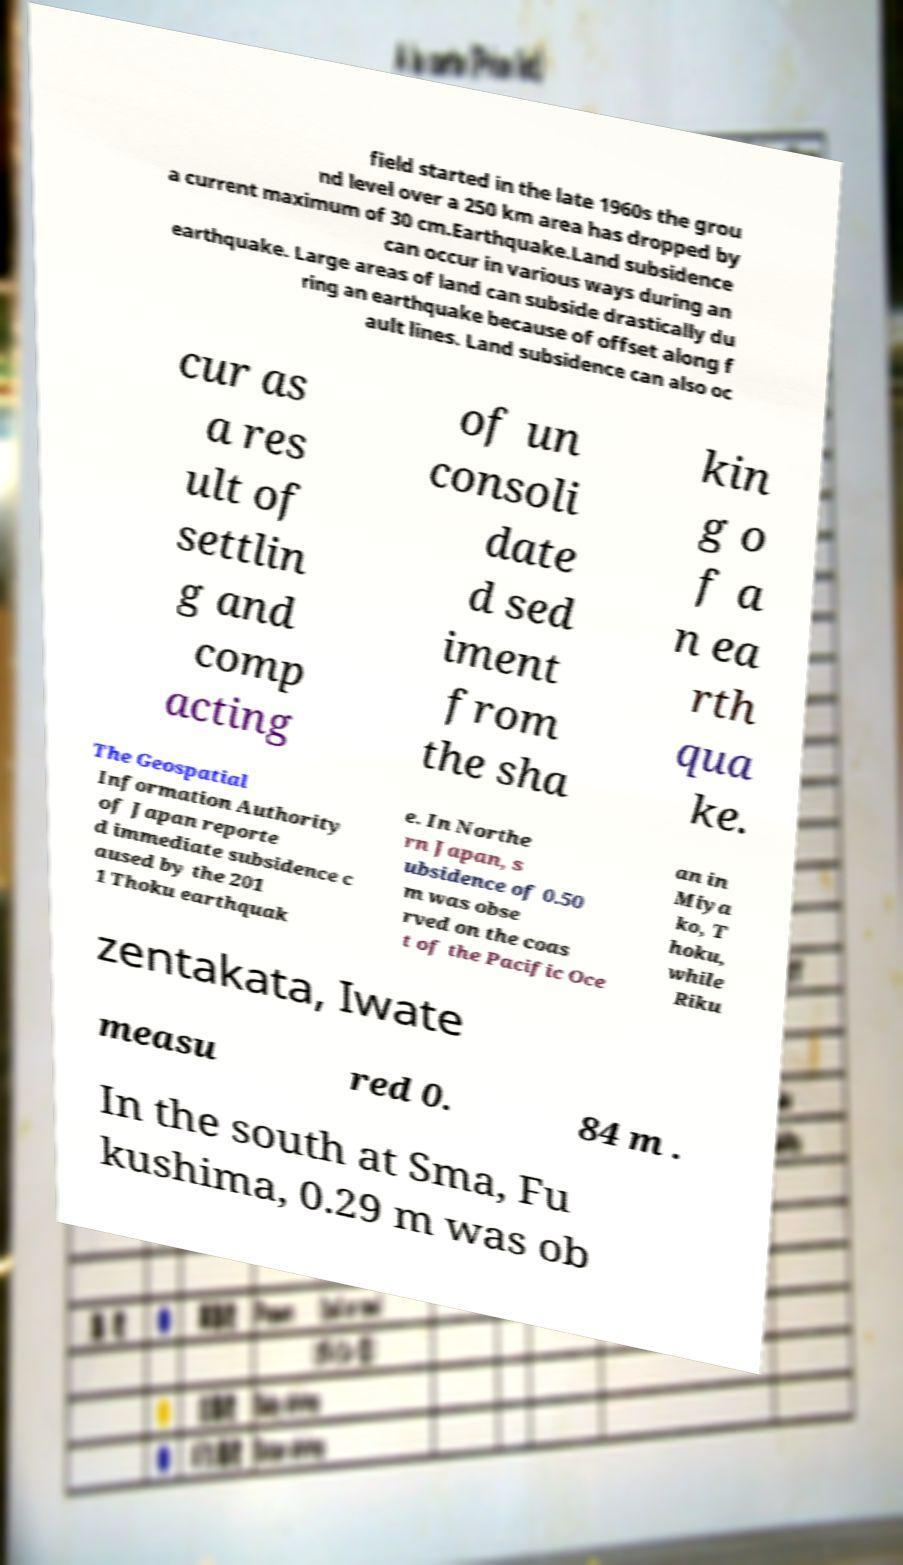Please read and relay the text visible in this image. What does it say? field started in the late 1960s the grou nd level over a 250 km area has dropped by a current maximum of 30 cm.Earthquake.Land subsidence can occur in various ways during an earthquake. Large areas of land can subside drastically du ring an earthquake because of offset along f ault lines. Land subsidence can also oc cur as a res ult of settlin g and comp acting of un consoli date d sed iment from the sha kin g o f a n ea rth qua ke. The Geospatial Information Authority of Japan reporte d immediate subsidence c aused by the 201 1 Thoku earthquak e. In Northe rn Japan, s ubsidence of 0.50 m was obse rved on the coas t of the Pacific Oce an in Miya ko, T hoku, while Riku zentakata, Iwate measu red 0. 84 m . In the south at Sma, Fu kushima, 0.29 m was ob 